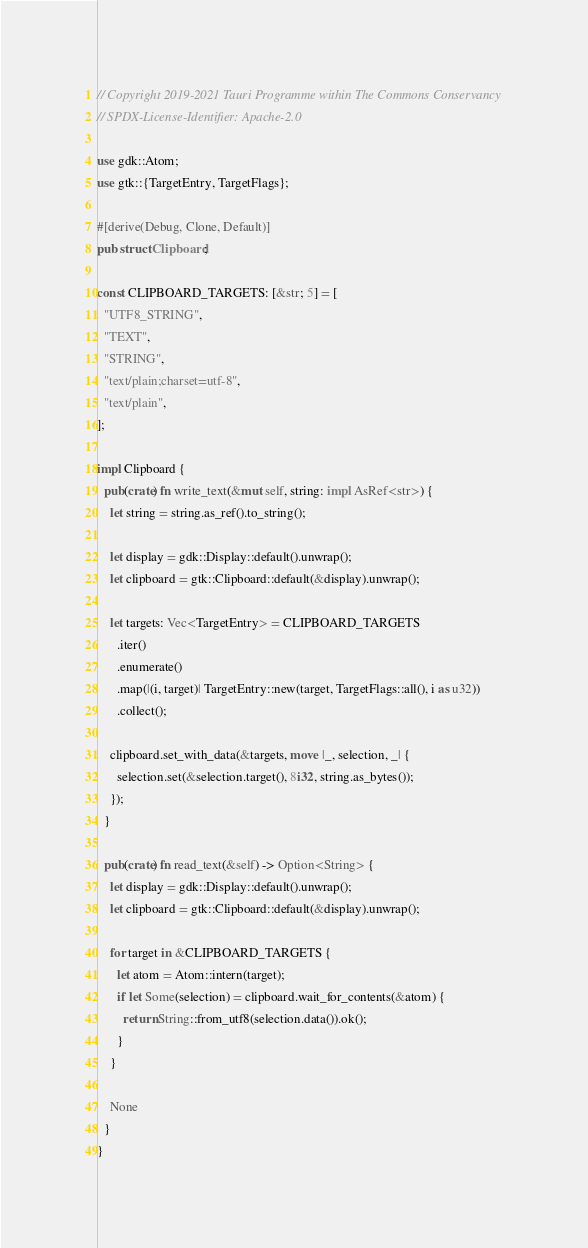Convert code to text. <code><loc_0><loc_0><loc_500><loc_500><_Rust_>// Copyright 2019-2021 Tauri Programme within The Commons Conservancy
// SPDX-License-Identifier: Apache-2.0

use gdk::Atom;
use gtk::{TargetEntry, TargetFlags};

#[derive(Debug, Clone, Default)]
pub struct Clipboard;

const CLIPBOARD_TARGETS: [&str; 5] = [
  "UTF8_STRING",
  "TEXT",
  "STRING",
  "text/plain;charset=utf-8",
  "text/plain",
];

impl Clipboard {
  pub(crate) fn write_text(&mut self, string: impl AsRef<str>) {
    let string = string.as_ref().to_string();

    let display = gdk::Display::default().unwrap();
    let clipboard = gtk::Clipboard::default(&display).unwrap();

    let targets: Vec<TargetEntry> = CLIPBOARD_TARGETS
      .iter()
      .enumerate()
      .map(|(i, target)| TargetEntry::new(target, TargetFlags::all(), i as u32))
      .collect();

    clipboard.set_with_data(&targets, move |_, selection, _| {
      selection.set(&selection.target(), 8i32, string.as_bytes());
    });
  }

  pub(crate) fn read_text(&self) -> Option<String> {
    let display = gdk::Display::default().unwrap();
    let clipboard = gtk::Clipboard::default(&display).unwrap();

    for target in &CLIPBOARD_TARGETS {
      let atom = Atom::intern(target);
      if let Some(selection) = clipboard.wait_for_contents(&atom) {
        return String::from_utf8(selection.data()).ok();
      }
    }

    None
  }
}
</code> 